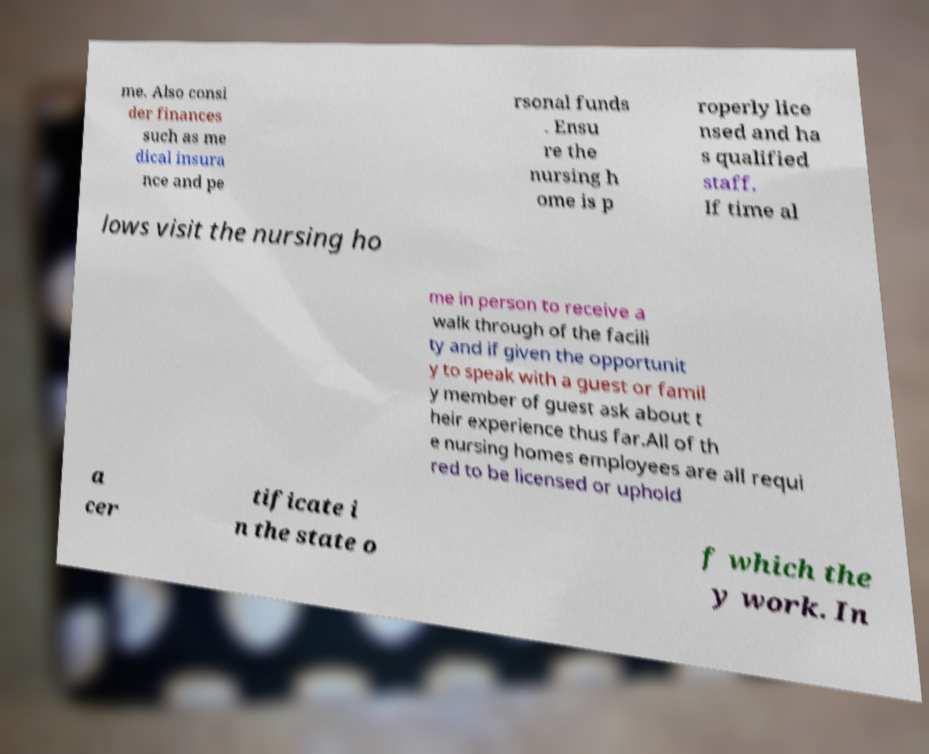Can you accurately transcribe the text from the provided image for me? me. Also consi der finances such as me dical insura nce and pe rsonal funds . Ensu re the nursing h ome is p roperly lice nsed and ha s qualified staff. If time al lows visit the nursing ho me in person to receive a walk through of the facili ty and if given the opportunit y to speak with a guest or famil y member of guest ask about t heir experience thus far.All of th e nursing homes employees are all requi red to be licensed or uphold a cer tificate i n the state o f which the y work. In 